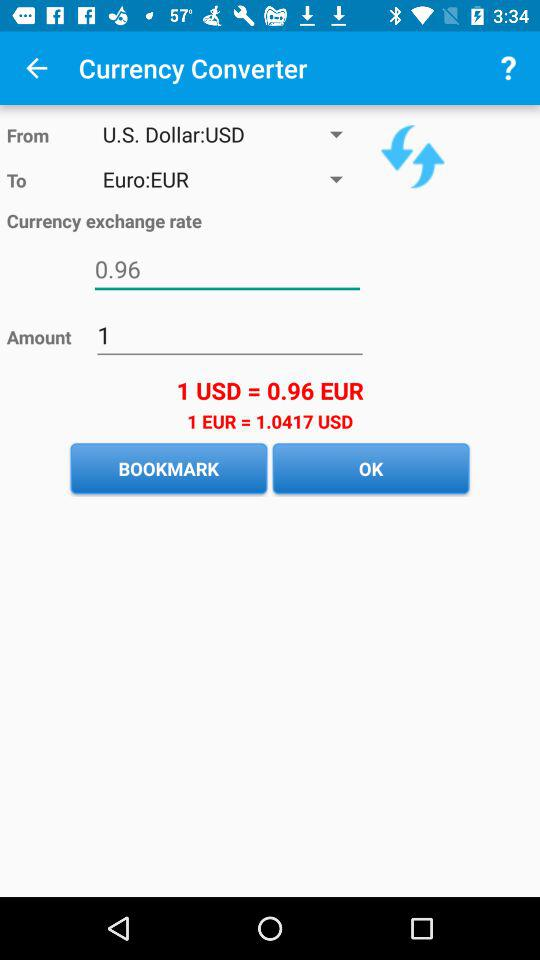How much more EUR is needed to get 1 USD?
Answer the question using a single word or phrase. 0.04 